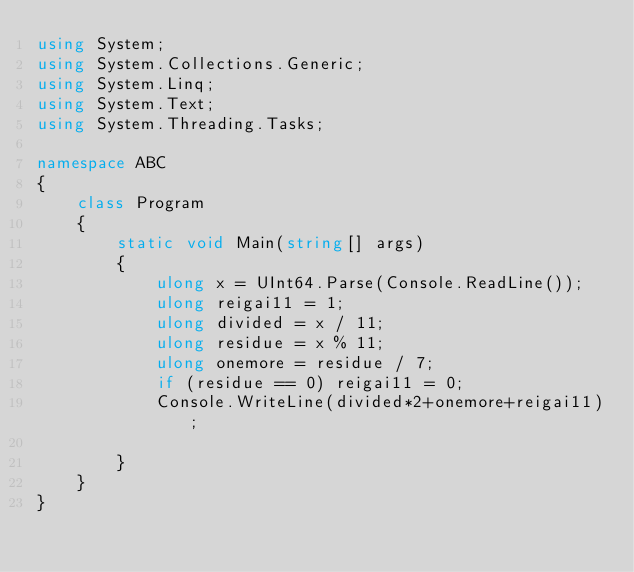Convert code to text. <code><loc_0><loc_0><loc_500><loc_500><_C#_>using System;
using System.Collections.Generic;
using System.Linq;
using System.Text;
using System.Threading.Tasks;

namespace ABC
{
    class Program
    {
        static void Main(string[] args)
        {
            ulong x = UInt64.Parse(Console.ReadLine());
            ulong reigai11 = 1;
            ulong divided = x / 11;
            ulong residue = x % 11;
            ulong onemore = residue / 7;
            if (residue == 0) reigai11 = 0; 
            Console.WriteLine(divided*2+onemore+reigai11);
            
        }
    }
}
</code> 